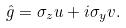Convert formula to latex. <formula><loc_0><loc_0><loc_500><loc_500>\hat { g } = \sigma _ { z } u + i \sigma _ { y } v .</formula> 